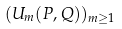Convert formula to latex. <formula><loc_0><loc_0><loc_500><loc_500>( U _ { m } ( P , Q ) ) _ { m \geq 1 }</formula> 